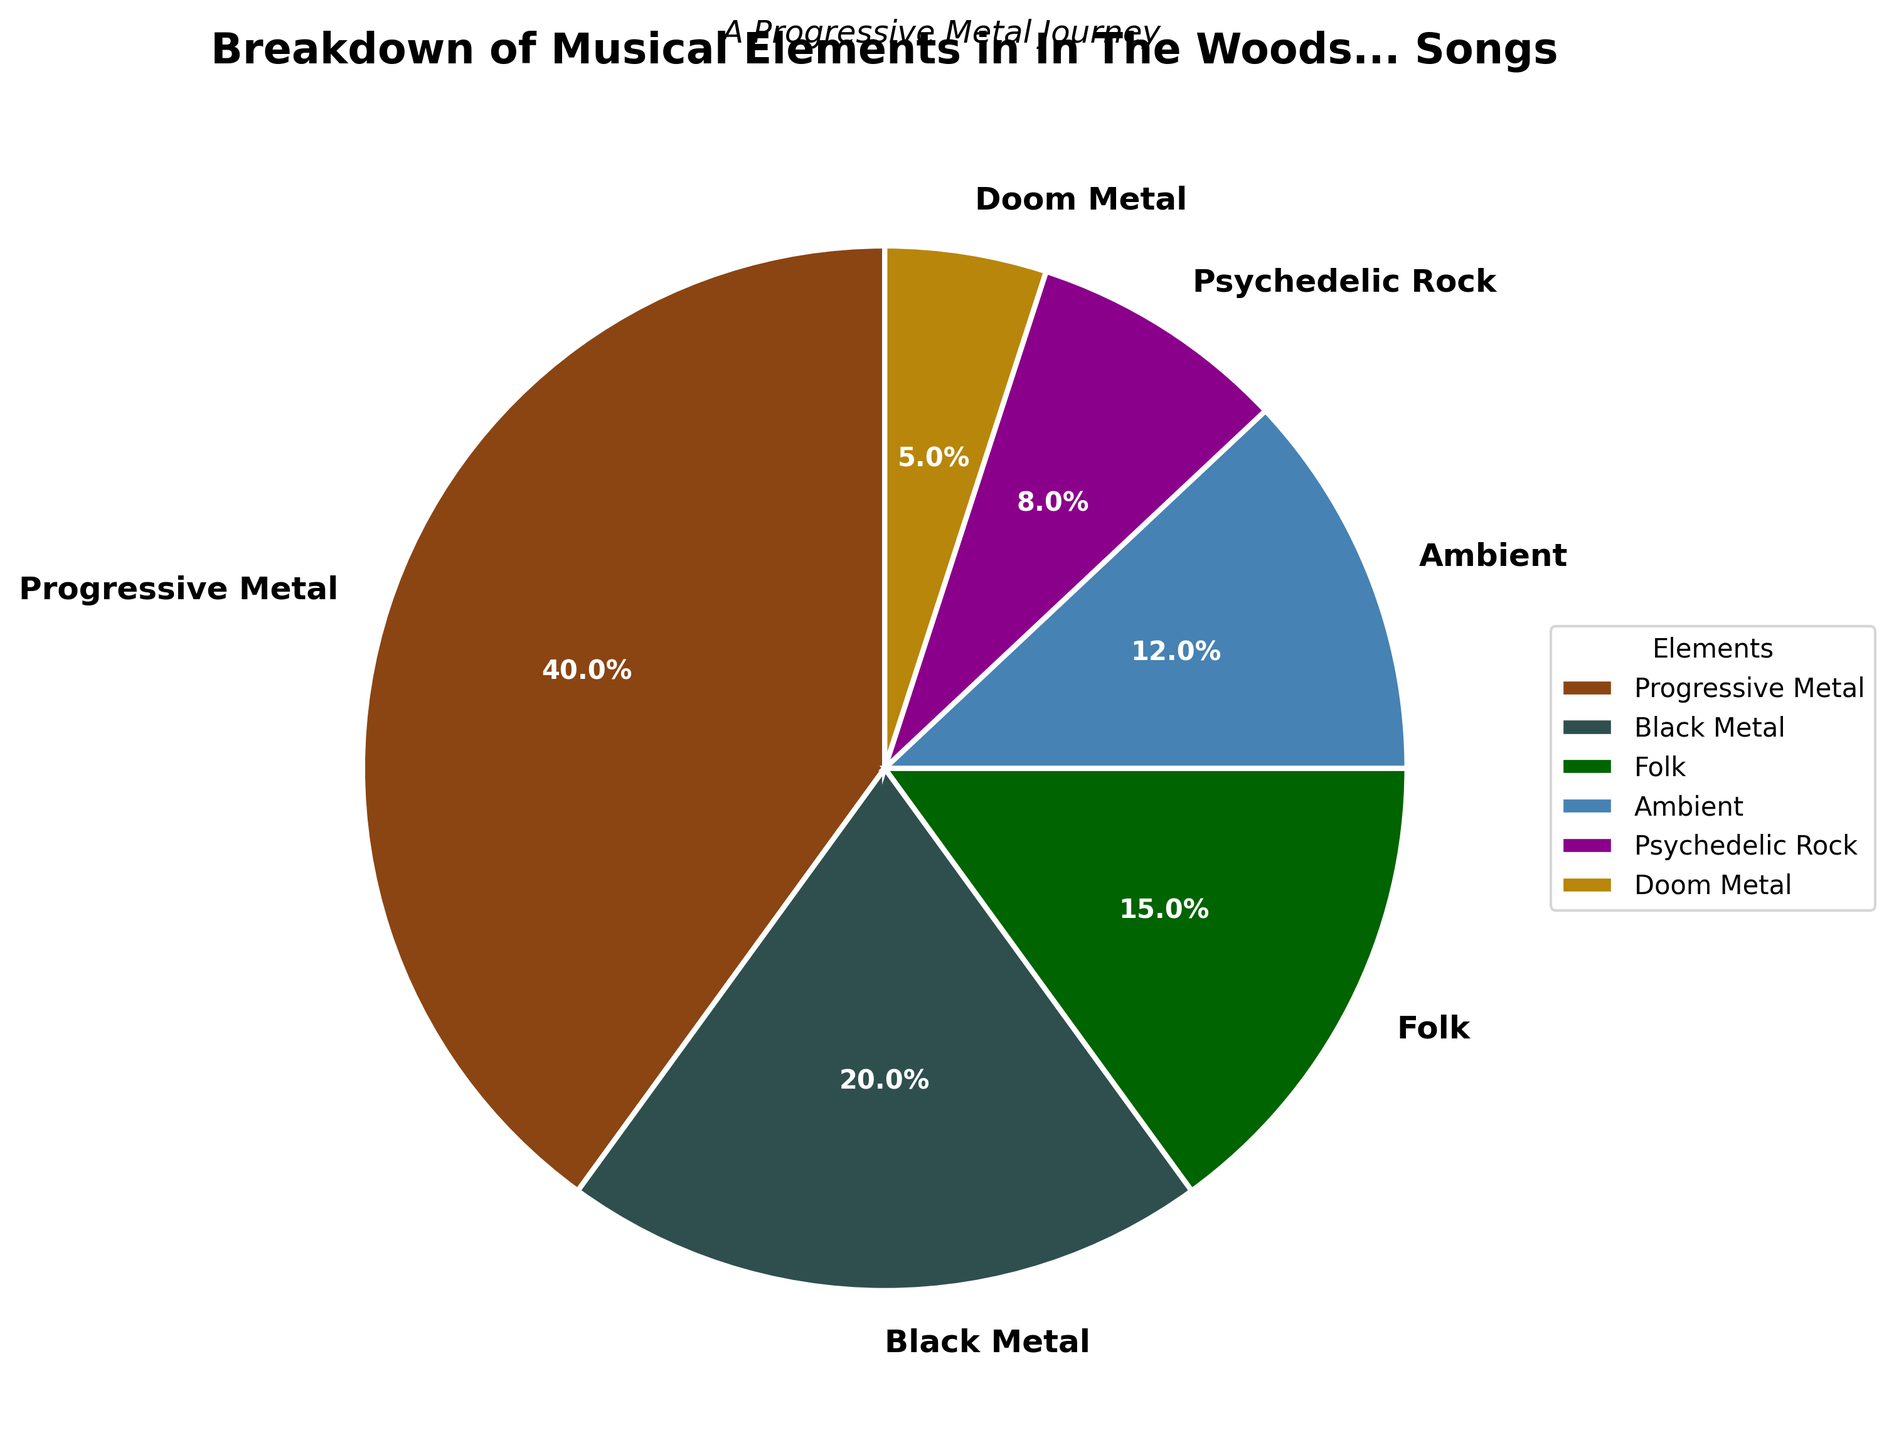Which musical element has the highest percentage in In The Woods... songs? Look at the pie chart and identify the element with the largest wedge. The Progressive Metal section is the largest.
Answer: Progressive Metal Which is more prevalent in the band's music, Folk or Doom Metal? By how much? Locate the Folk and Doom Metal sections in the pie chart. Compare the sizes of their wedges and the percentages labeled. Folk is 15% and Doom Metal is 5%, giving a difference of 10%.
Answer: Folk, by 10% How much do Ambient and Psychedelic Rock together contribute to the music of In The Woods...? Add the percentages of Ambient (12%) and Psychedelic Rock (8%) together. The sum is 12% + 8% = 20%.
Answer: 20% Which two elements have the closest percentages? Compare the percentages of all musical elements. Folk is 15% and Ambient is 12%. These two elements have the closest values.
Answer: Folk and Ambient What is the total percentage of the elements excluding Progressive Metal and Black Metal? Subtract the percentages of Progressive Metal (40%) and Black Metal (20%) from 100%. The calculation is 100% - 40% - 20% = 40%.
Answer: 40% How does the proportion of Black Metal compare to that of Psychedelic Rock in the band’s music? Observe the pie chart and compare the labeled percentages. Black Metal constitutes 20%, while Psychedelic Rock is 8%. Hence, Black Metal is more prevalent.
Answer: Black Metal is more prevalent How many elements each make up less than 10% of the band's music? Identify the wedges whose percentages are less than 10%. Only Psychedelic Rock (8%) and Doom Metal (5%) fall under this category. There are two such elements.
Answer: 2 Which musical element is represented by the green color? Observe the color coding in the pie chart and identify which element is associated with green. Folk is represented by green.
Answer: Folk What percentage range encompasses the smallest and largest musical elements in In The Woods… songs? Identify the percentages of the smallest and largest elements. The smallest is Doom Metal at 5%, and the largest is Progressive Metal at 40%. The range is 5% to 40%.
Answer: 5% to 40% Is the sum of the percentages of Ambient and Folk greater or lesser than that of Progressive Metal? Add the percentages of Ambient (12%) and Folk (15%), and compare with Progressive Metal (40%). The sum is 27%, which is less than 40%.
Answer: Lesser 